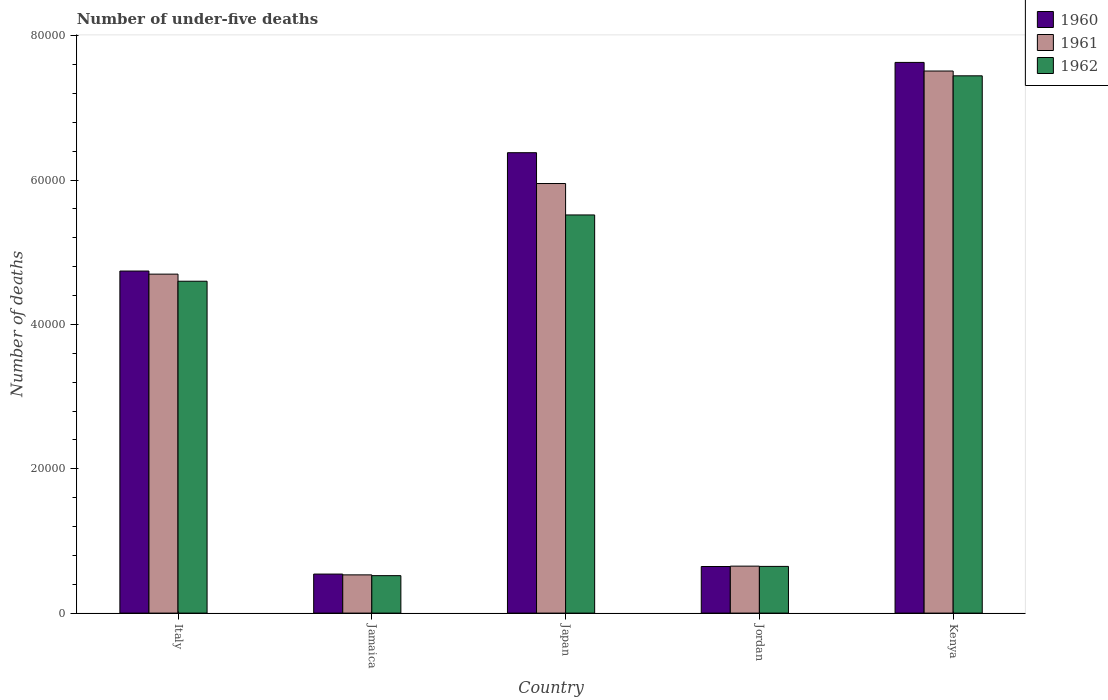How many groups of bars are there?
Offer a very short reply. 5. How many bars are there on the 5th tick from the left?
Make the answer very short. 3. What is the number of under-five deaths in 1962 in Jamaica?
Offer a very short reply. 5189. Across all countries, what is the maximum number of under-five deaths in 1961?
Offer a terse response. 7.51e+04. Across all countries, what is the minimum number of under-five deaths in 1961?
Your response must be concise. 5297. In which country was the number of under-five deaths in 1961 maximum?
Offer a terse response. Kenya. In which country was the number of under-five deaths in 1961 minimum?
Keep it short and to the point. Jamaica. What is the total number of under-five deaths in 1962 in the graph?
Ensure brevity in your answer.  1.87e+05. What is the difference between the number of under-five deaths in 1962 in Italy and that in Kenya?
Ensure brevity in your answer.  -2.85e+04. What is the difference between the number of under-five deaths in 1960 in Jamaica and the number of under-five deaths in 1962 in Kenya?
Provide a short and direct response. -6.90e+04. What is the average number of under-five deaths in 1960 per country?
Make the answer very short. 3.99e+04. What is the difference between the number of under-five deaths of/in 1960 and number of under-five deaths of/in 1961 in Kenya?
Your answer should be compact. 1193. In how many countries, is the number of under-five deaths in 1960 greater than 76000?
Make the answer very short. 1. What is the ratio of the number of under-five deaths in 1962 in Italy to that in Jamaica?
Ensure brevity in your answer.  8.86. Is the difference between the number of under-five deaths in 1960 in Jamaica and Jordan greater than the difference between the number of under-five deaths in 1961 in Jamaica and Jordan?
Offer a very short reply. Yes. What is the difference between the highest and the second highest number of under-five deaths in 1960?
Provide a short and direct response. -2.89e+04. What is the difference between the highest and the lowest number of under-five deaths in 1961?
Your answer should be compact. 6.98e+04. Is the sum of the number of under-five deaths in 1960 in Italy and Japan greater than the maximum number of under-five deaths in 1962 across all countries?
Your response must be concise. Yes. What does the 3rd bar from the left in Jordan represents?
Keep it short and to the point. 1962. What does the 3rd bar from the right in Jordan represents?
Your answer should be very brief. 1960. Is it the case that in every country, the sum of the number of under-five deaths in 1962 and number of under-five deaths in 1961 is greater than the number of under-five deaths in 1960?
Keep it short and to the point. Yes. How many bars are there?
Keep it short and to the point. 15. Are all the bars in the graph horizontal?
Ensure brevity in your answer.  No. How many countries are there in the graph?
Offer a very short reply. 5. How are the legend labels stacked?
Your response must be concise. Vertical. What is the title of the graph?
Provide a short and direct response. Number of under-five deaths. What is the label or title of the Y-axis?
Your response must be concise. Number of deaths. What is the Number of deaths of 1960 in Italy?
Offer a terse response. 4.74e+04. What is the Number of deaths of 1961 in Italy?
Provide a short and direct response. 4.70e+04. What is the Number of deaths in 1962 in Italy?
Provide a short and direct response. 4.60e+04. What is the Number of deaths of 1960 in Jamaica?
Your answer should be very brief. 5408. What is the Number of deaths in 1961 in Jamaica?
Ensure brevity in your answer.  5297. What is the Number of deaths of 1962 in Jamaica?
Provide a short and direct response. 5189. What is the Number of deaths of 1960 in Japan?
Provide a succinct answer. 6.38e+04. What is the Number of deaths in 1961 in Japan?
Keep it short and to the point. 5.95e+04. What is the Number of deaths of 1962 in Japan?
Make the answer very short. 5.52e+04. What is the Number of deaths in 1960 in Jordan?
Provide a short and direct response. 6455. What is the Number of deaths of 1961 in Jordan?
Ensure brevity in your answer.  6506. What is the Number of deaths of 1962 in Jordan?
Your answer should be compact. 6471. What is the Number of deaths of 1960 in Kenya?
Offer a terse response. 7.63e+04. What is the Number of deaths of 1961 in Kenya?
Provide a succinct answer. 7.51e+04. What is the Number of deaths in 1962 in Kenya?
Offer a terse response. 7.44e+04. Across all countries, what is the maximum Number of deaths of 1960?
Give a very brief answer. 7.63e+04. Across all countries, what is the maximum Number of deaths in 1961?
Offer a terse response. 7.51e+04. Across all countries, what is the maximum Number of deaths of 1962?
Your answer should be very brief. 7.44e+04. Across all countries, what is the minimum Number of deaths in 1960?
Make the answer very short. 5408. Across all countries, what is the minimum Number of deaths in 1961?
Your response must be concise. 5297. Across all countries, what is the minimum Number of deaths of 1962?
Offer a very short reply. 5189. What is the total Number of deaths of 1960 in the graph?
Offer a very short reply. 1.99e+05. What is the total Number of deaths of 1961 in the graph?
Give a very brief answer. 1.93e+05. What is the total Number of deaths in 1962 in the graph?
Your answer should be very brief. 1.87e+05. What is the difference between the Number of deaths in 1960 in Italy and that in Jamaica?
Provide a succinct answer. 4.20e+04. What is the difference between the Number of deaths of 1961 in Italy and that in Jamaica?
Your response must be concise. 4.17e+04. What is the difference between the Number of deaths of 1962 in Italy and that in Jamaica?
Offer a very short reply. 4.08e+04. What is the difference between the Number of deaths of 1960 in Italy and that in Japan?
Offer a very short reply. -1.64e+04. What is the difference between the Number of deaths in 1961 in Italy and that in Japan?
Your answer should be compact. -1.26e+04. What is the difference between the Number of deaths of 1962 in Italy and that in Japan?
Your answer should be very brief. -9184. What is the difference between the Number of deaths in 1960 in Italy and that in Jordan?
Keep it short and to the point. 4.09e+04. What is the difference between the Number of deaths of 1961 in Italy and that in Jordan?
Provide a succinct answer. 4.05e+04. What is the difference between the Number of deaths of 1962 in Italy and that in Jordan?
Keep it short and to the point. 3.95e+04. What is the difference between the Number of deaths in 1960 in Italy and that in Kenya?
Make the answer very short. -2.89e+04. What is the difference between the Number of deaths in 1961 in Italy and that in Kenya?
Provide a succinct answer. -2.81e+04. What is the difference between the Number of deaths of 1962 in Italy and that in Kenya?
Keep it short and to the point. -2.85e+04. What is the difference between the Number of deaths of 1960 in Jamaica and that in Japan?
Your response must be concise. -5.84e+04. What is the difference between the Number of deaths in 1961 in Jamaica and that in Japan?
Offer a terse response. -5.42e+04. What is the difference between the Number of deaths of 1962 in Jamaica and that in Japan?
Ensure brevity in your answer.  -5.00e+04. What is the difference between the Number of deaths in 1960 in Jamaica and that in Jordan?
Give a very brief answer. -1047. What is the difference between the Number of deaths in 1961 in Jamaica and that in Jordan?
Your answer should be very brief. -1209. What is the difference between the Number of deaths of 1962 in Jamaica and that in Jordan?
Keep it short and to the point. -1282. What is the difference between the Number of deaths in 1960 in Jamaica and that in Kenya?
Your response must be concise. -7.09e+04. What is the difference between the Number of deaths of 1961 in Jamaica and that in Kenya?
Your answer should be compact. -6.98e+04. What is the difference between the Number of deaths in 1962 in Jamaica and that in Kenya?
Your answer should be compact. -6.93e+04. What is the difference between the Number of deaths in 1960 in Japan and that in Jordan?
Offer a very short reply. 5.73e+04. What is the difference between the Number of deaths of 1961 in Japan and that in Jordan?
Make the answer very short. 5.30e+04. What is the difference between the Number of deaths in 1962 in Japan and that in Jordan?
Your answer should be compact. 4.87e+04. What is the difference between the Number of deaths of 1960 in Japan and that in Kenya?
Make the answer very short. -1.25e+04. What is the difference between the Number of deaths in 1961 in Japan and that in Kenya?
Provide a succinct answer. -1.56e+04. What is the difference between the Number of deaths in 1962 in Japan and that in Kenya?
Ensure brevity in your answer.  -1.93e+04. What is the difference between the Number of deaths in 1960 in Jordan and that in Kenya?
Your response must be concise. -6.98e+04. What is the difference between the Number of deaths in 1961 in Jordan and that in Kenya?
Provide a succinct answer. -6.86e+04. What is the difference between the Number of deaths in 1962 in Jordan and that in Kenya?
Make the answer very short. -6.80e+04. What is the difference between the Number of deaths in 1960 in Italy and the Number of deaths in 1961 in Jamaica?
Your answer should be very brief. 4.21e+04. What is the difference between the Number of deaths of 1960 in Italy and the Number of deaths of 1962 in Jamaica?
Keep it short and to the point. 4.22e+04. What is the difference between the Number of deaths of 1961 in Italy and the Number of deaths of 1962 in Jamaica?
Give a very brief answer. 4.18e+04. What is the difference between the Number of deaths in 1960 in Italy and the Number of deaths in 1961 in Japan?
Offer a very short reply. -1.21e+04. What is the difference between the Number of deaths in 1960 in Italy and the Number of deaths in 1962 in Japan?
Keep it short and to the point. -7771. What is the difference between the Number of deaths of 1961 in Italy and the Number of deaths of 1962 in Japan?
Offer a very short reply. -8200. What is the difference between the Number of deaths in 1960 in Italy and the Number of deaths in 1961 in Jordan?
Offer a terse response. 4.09e+04. What is the difference between the Number of deaths in 1960 in Italy and the Number of deaths in 1962 in Jordan?
Provide a short and direct response. 4.09e+04. What is the difference between the Number of deaths of 1961 in Italy and the Number of deaths of 1962 in Jordan?
Provide a short and direct response. 4.05e+04. What is the difference between the Number of deaths in 1960 in Italy and the Number of deaths in 1961 in Kenya?
Provide a short and direct response. -2.77e+04. What is the difference between the Number of deaths of 1960 in Italy and the Number of deaths of 1962 in Kenya?
Keep it short and to the point. -2.70e+04. What is the difference between the Number of deaths in 1961 in Italy and the Number of deaths in 1962 in Kenya?
Provide a short and direct response. -2.75e+04. What is the difference between the Number of deaths in 1960 in Jamaica and the Number of deaths in 1961 in Japan?
Keep it short and to the point. -5.41e+04. What is the difference between the Number of deaths of 1960 in Jamaica and the Number of deaths of 1962 in Japan?
Keep it short and to the point. -4.98e+04. What is the difference between the Number of deaths in 1961 in Jamaica and the Number of deaths in 1962 in Japan?
Offer a very short reply. -4.99e+04. What is the difference between the Number of deaths in 1960 in Jamaica and the Number of deaths in 1961 in Jordan?
Ensure brevity in your answer.  -1098. What is the difference between the Number of deaths of 1960 in Jamaica and the Number of deaths of 1962 in Jordan?
Give a very brief answer. -1063. What is the difference between the Number of deaths of 1961 in Jamaica and the Number of deaths of 1962 in Jordan?
Your response must be concise. -1174. What is the difference between the Number of deaths in 1960 in Jamaica and the Number of deaths in 1961 in Kenya?
Give a very brief answer. -6.97e+04. What is the difference between the Number of deaths in 1960 in Jamaica and the Number of deaths in 1962 in Kenya?
Provide a succinct answer. -6.90e+04. What is the difference between the Number of deaths in 1961 in Jamaica and the Number of deaths in 1962 in Kenya?
Provide a short and direct response. -6.91e+04. What is the difference between the Number of deaths of 1960 in Japan and the Number of deaths of 1961 in Jordan?
Keep it short and to the point. 5.73e+04. What is the difference between the Number of deaths in 1960 in Japan and the Number of deaths in 1962 in Jordan?
Provide a succinct answer. 5.73e+04. What is the difference between the Number of deaths in 1961 in Japan and the Number of deaths in 1962 in Jordan?
Your answer should be very brief. 5.30e+04. What is the difference between the Number of deaths in 1960 in Japan and the Number of deaths in 1961 in Kenya?
Offer a terse response. -1.13e+04. What is the difference between the Number of deaths in 1960 in Japan and the Number of deaths in 1962 in Kenya?
Make the answer very short. -1.07e+04. What is the difference between the Number of deaths in 1961 in Japan and the Number of deaths in 1962 in Kenya?
Your response must be concise. -1.49e+04. What is the difference between the Number of deaths in 1960 in Jordan and the Number of deaths in 1961 in Kenya?
Ensure brevity in your answer.  -6.86e+04. What is the difference between the Number of deaths in 1960 in Jordan and the Number of deaths in 1962 in Kenya?
Your response must be concise. -6.80e+04. What is the difference between the Number of deaths in 1961 in Jordan and the Number of deaths in 1962 in Kenya?
Your answer should be compact. -6.79e+04. What is the average Number of deaths in 1960 per country?
Your answer should be very brief. 3.99e+04. What is the average Number of deaths of 1961 per country?
Your response must be concise. 3.87e+04. What is the average Number of deaths of 1962 per country?
Offer a terse response. 3.74e+04. What is the difference between the Number of deaths in 1960 and Number of deaths in 1961 in Italy?
Your response must be concise. 429. What is the difference between the Number of deaths in 1960 and Number of deaths in 1962 in Italy?
Your answer should be compact. 1413. What is the difference between the Number of deaths of 1961 and Number of deaths of 1962 in Italy?
Provide a succinct answer. 984. What is the difference between the Number of deaths of 1960 and Number of deaths of 1961 in Jamaica?
Provide a succinct answer. 111. What is the difference between the Number of deaths in 1960 and Number of deaths in 1962 in Jamaica?
Make the answer very short. 219. What is the difference between the Number of deaths of 1961 and Number of deaths of 1962 in Jamaica?
Give a very brief answer. 108. What is the difference between the Number of deaths in 1960 and Number of deaths in 1961 in Japan?
Provide a succinct answer. 4272. What is the difference between the Number of deaths in 1960 and Number of deaths in 1962 in Japan?
Your answer should be very brief. 8625. What is the difference between the Number of deaths of 1961 and Number of deaths of 1962 in Japan?
Offer a terse response. 4353. What is the difference between the Number of deaths in 1960 and Number of deaths in 1961 in Jordan?
Offer a very short reply. -51. What is the difference between the Number of deaths of 1960 and Number of deaths of 1962 in Jordan?
Make the answer very short. -16. What is the difference between the Number of deaths of 1960 and Number of deaths of 1961 in Kenya?
Ensure brevity in your answer.  1193. What is the difference between the Number of deaths of 1960 and Number of deaths of 1962 in Kenya?
Give a very brief answer. 1857. What is the difference between the Number of deaths in 1961 and Number of deaths in 1962 in Kenya?
Your answer should be very brief. 664. What is the ratio of the Number of deaths in 1960 in Italy to that in Jamaica?
Keep it short and to the point. 8.76. What is the ratio of the Number of deaths in 1961 in Italy to that in Jamaica?
Your answer should be very brief. 8.87. What is the ratio of the Number of deaths in 1962 in Italy to that in Jamaica?
Provide a succinct answer. 8.86. What is the ratio of the Number of deaths of 1960 in Italy to that in Japan?
Ensure brevity in your answer.  0.74. What is the ratio of the Number of deaths in 1961 in Italy to that in Japan?
Make the answer very short. 0.79. What is the ratio of the Number of deaths of 1962 in Italy to that in Japan?
Offer a terse response. 0.83. What is the ratio of the Number of deaths of 1960 in Italy to that in Jordan?
Keep it short and to the point. 7.34. What is the ratio of the Number of deaths in 1961 in Italy to that in Jordan?
Provide a succinct answer. 7.22. What is the ratio of the Number of deaths of 1962 in Italy to that in Jordan?
Your answer should be very brief. 7.11. What is the ratio of the Number of deaths in 1960 in Italy to that in Kenya?
Provide a succinct answer. 0.62. What is the ratio of the Number of deaths in 1961 in Italy to that in Kenya?
Ensure brevity in your answer.  0.63. What is the ratio of the Number of deaths of 1962 in Italy to that in Kenya?
Your answer should be compact. 0.62. What is the ratio of the Number of deaths in 1960 in Jamaica to that in Japan?
Your response must be concise. 0.08. What is the ratio of the Number of deaths in 1961 in Jamaica to that in Japan?
Give a very brief answer. 0.09. What is the ratio of the Number of deaths of 1962 in Jamaica to that in Japan?
Your response must be concise. 0.09. What is the ratio of the Number of deaths of 1960 in Jamaica to that in Jordan?
Offer a terse response. 0.84. What is the ratio of the Number of deaths of 1961 in Jamaica to that in Jordan?
Ensure brevity in your answer.  0.81. What is the ratio of the Number of deaths in 1962 in Jamaica to that in Jordan?
Your answer should be compact. 0.8. What is the ratio of the Number of deaths in 1960 in Jamaica to that in Kenya?
Your response must be concise. 0.07. What is the ratio of the Number of deaths in 1961 in Jamaica to that in Kenya?
Offer a terse response. 0.07. What is the ratio of the Number of deaths of 1962 in Jamaica to that in Kenya?
Provide a short and direct response. 0.07. What is the ratio of the Number of deaths in 1960 in Japan to that in Jordan?
Keep it short and to the point. 9.88. What is the ratio of the Number of deaths in 1961 in Japan to that in Jordan?
Give a very brief answer. 9.15. What is the ratio of the Number of deaths of 1962 in Japan to that in Jordan?
Make the answer very short. 8.52. What is the ratio of the Number of deaths of 1960 in Japan to that in Kenya?
Your response must be concise. 0.84. What is the ratio of the Number of deaths in 1961 in Japan to that in Kenya?
Offer a terse response. 0.79. What is the ratio of the Number of deaths of 1962 in Japan to that in Kenya?
Ensure brevity in your answer.  0.74. What is the ratio of the Number of deaths in 1960 in Jordan to that in Kenya?
Keep it short and to the point. 0.08. What is the ratio of the Number of deaths in 1961 in Jordan to that in Kenya?
Keep it short and to the point. 0.09. What is the ratio of the Number of deaths of 1962 in Jordan to that in Kenya?
Offer a very short reply. 0.09. What is the difference between the highest and the second highest Number of deaths in 1960?
Keep it short and to the point. 1.25e+04. What is the difference between the highest and the second highest Number of deaths of 1961?
Provide a short and direct response. 1.56e+04. What is the difference between the highest and the second highest Number of deaths of 1962?
Provide a succinct answer. 1.93e+04. What is the difference between the highest and the lowest Number of deaths in 1960?
Keep it short and to the point. 7.09e+04. What is the difference between the highest and the lowest Number of deaths of 1961?
Your answer should be very brief. 6.98e+04. What is the difference between the highest and the lowest Number of deaths in 1962?
Your answer should be compact. 6.93e+04. 